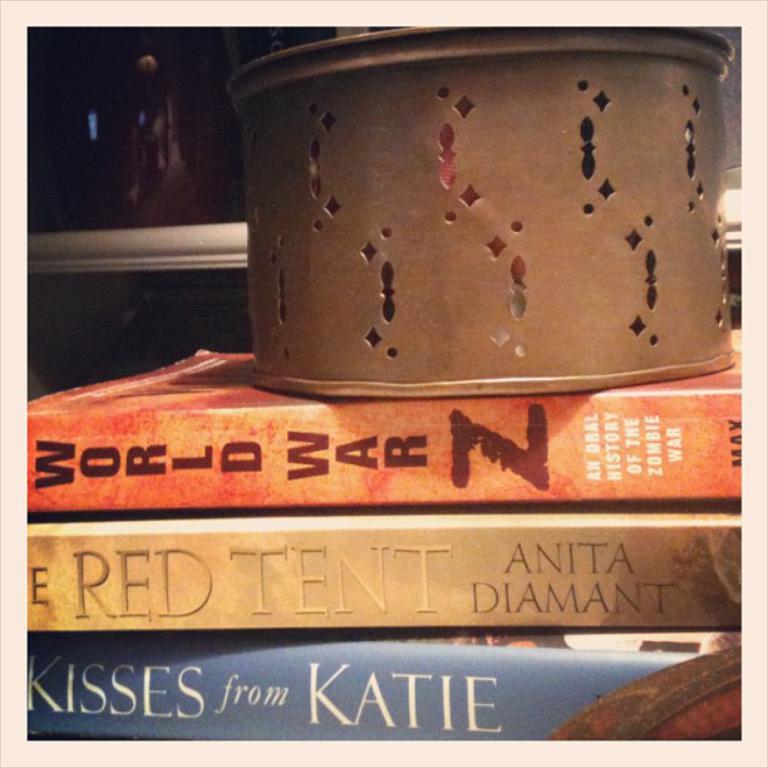What is the color of the tent mentioned in the book?
Offer a terse response. Red. Who is the author of the book in the middle?
Your answer should be compact. Anita diamant. 